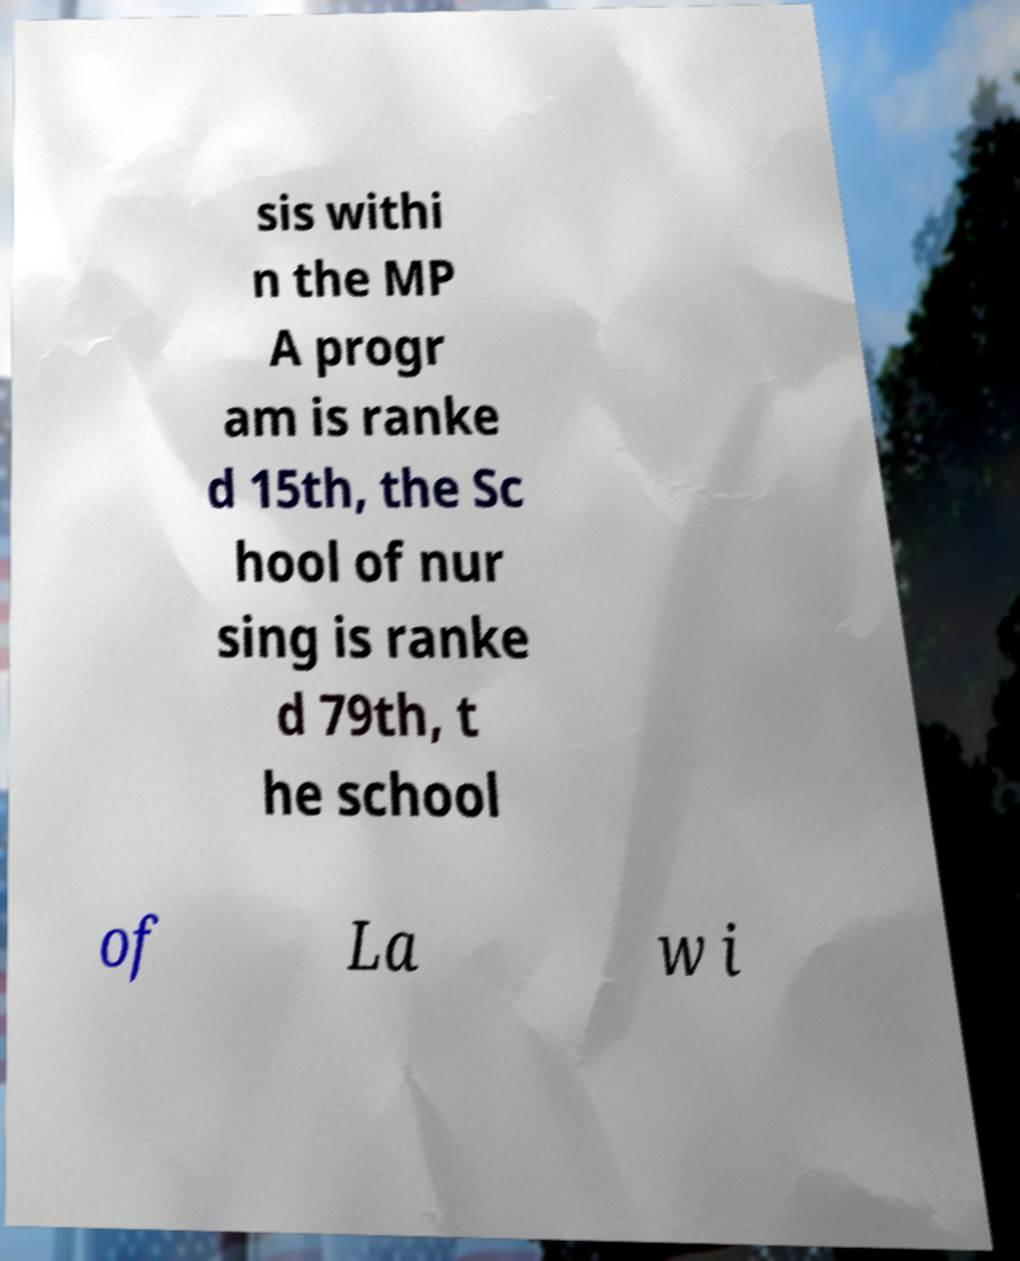Could you assist in decoding the text presented in this image and type it out clearly? sis withi n the MP A progr am is ranke d 15th, the Sc hool of nur sing is ranke d 79th, t he school of La w i 